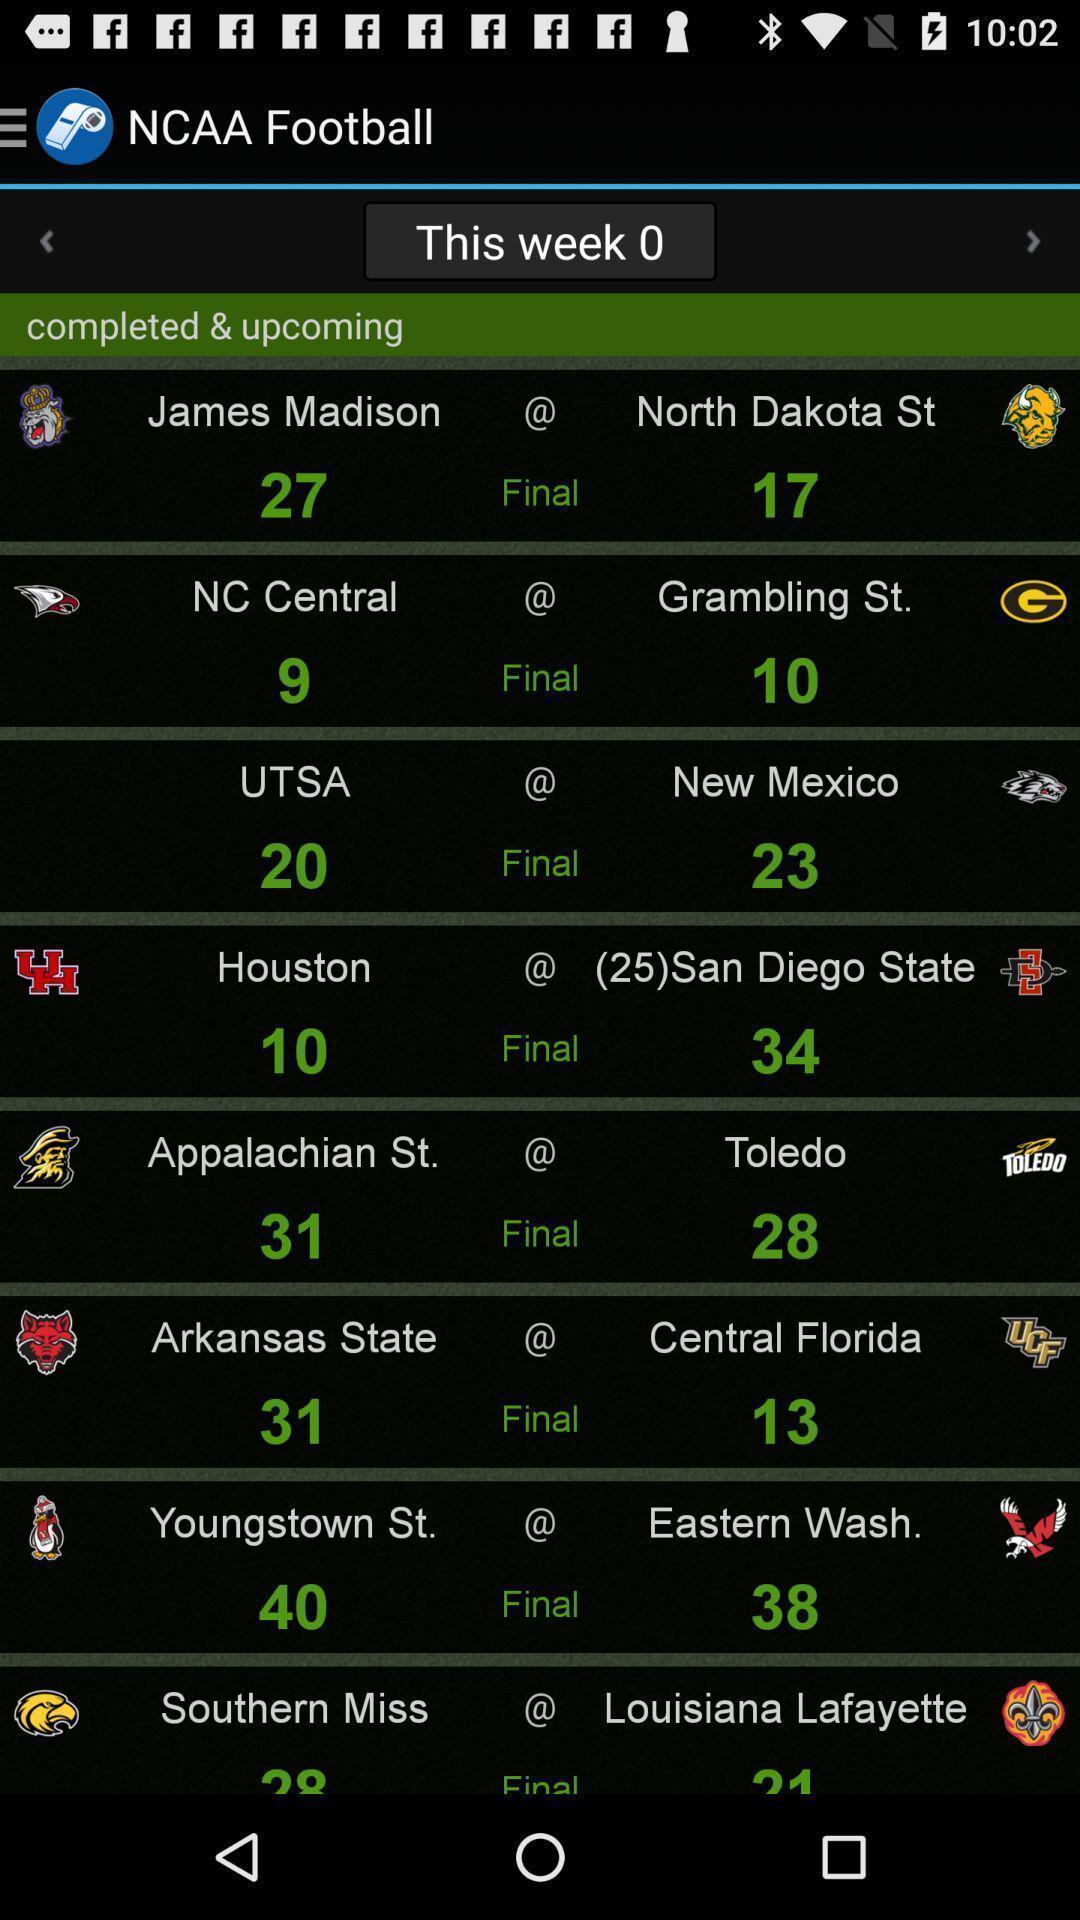What details can you identify in this image? Screen showing list of various teams with rankings. 